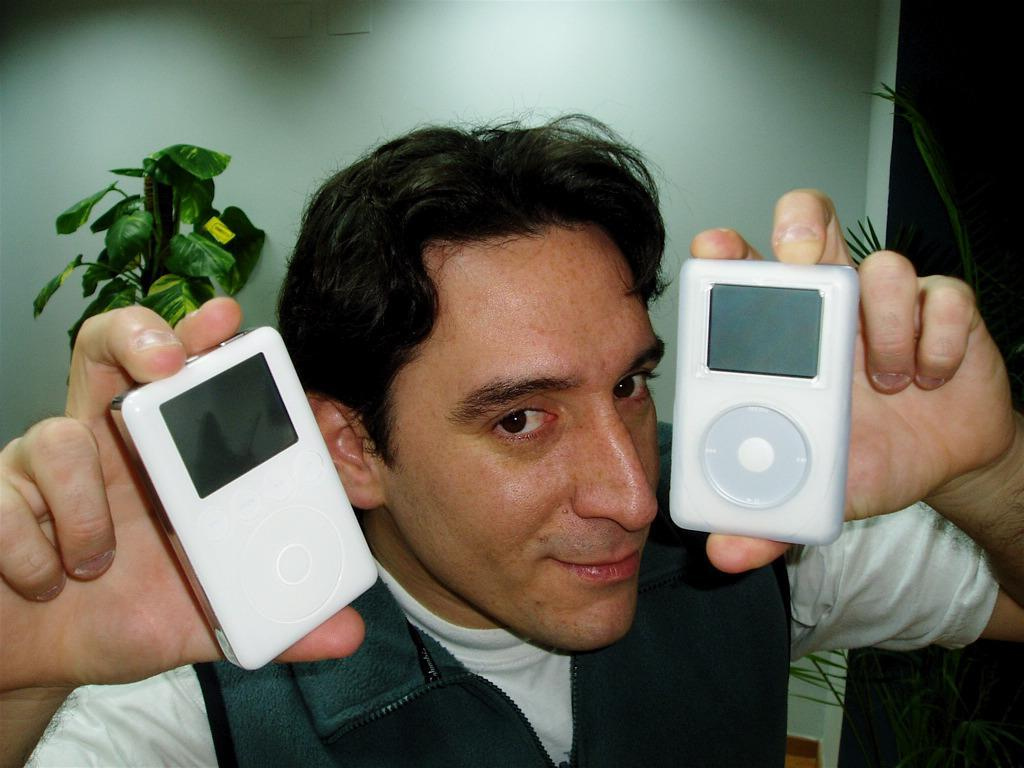Who is present in the image? There is a man in the image. What is the man holding in the image? The man is holding two iPads. What can be seen behind the man? There are two plants behind the man. What is located behind the plants? There is a wall behind the plants. Where is the sister wearing a veil in the image? There is no sister wearing a veil present in the image. What type of alley can be seen in the image? There is no alley present in the image. 